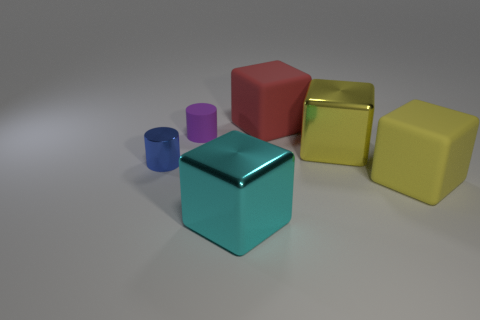Add 2 large red matte things. How many objects exist? 8 Subtract all cubes. How many objects are left? 2 Add 6 gray rubber objects. How many gray rubber objects exist? 6 Subtract 0 brown blocks. How many objects are left? 6 Subtract all cyan blocks. Subtract all small purple objects. How many objects are left? 4 Add 6 big yellow shiny blocks. How many big yellow shiny blocks are left? 7 